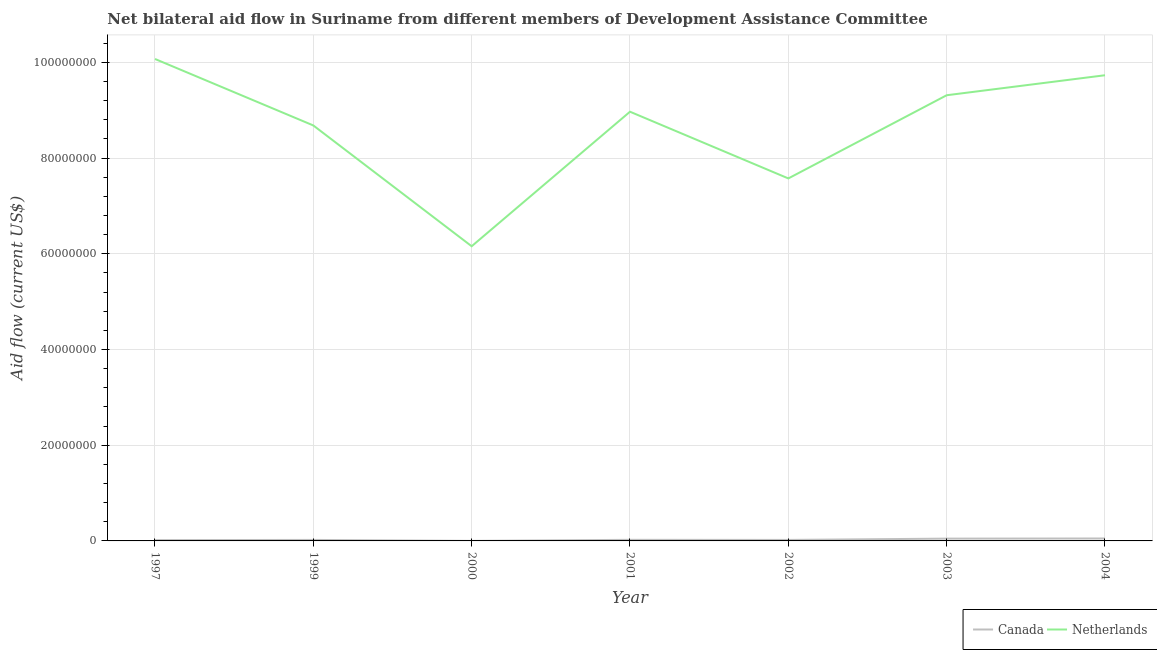Is the number of lines equal to the number of legend labels?
Your answer should be very brief. Yes. What is the amount of aid given by netherlands in 2004?
Provide a succinct answer. 9.73e+07. Across all years, what is the maximum amount of aid given by netherlands?
Provide a succinct answer. 1.01e+08. Across all years, what is the minimum amount of aid given by netherlands?
Your answer should be compact. 6.16e+07. What is the total amount of aid given by netherlands in the graph?
Ensure brevity in your answer.  6.05e+08. What is the difference between the amount of aid given by netherlands in 2001 and that in 2003?
Provide a short and direct response. -3.44e+06. What is the difference between the amount of aid given by netherlands in 2003 and the amount of aid given by canada in 1997?
Offer a very short reply. 9.30e+07. What is the average amount of aid given by netherlands per year?
Ensure brevity in your answer.  8.64e+07. In the year 1997, what is the difference between the amount of aid given by netherlands and amount of aid given by canada?
Offer a terse response. 1.01e+08. What is the ratio of the amount of aid given by netherlands in 2000 to that in 2001?
Your response must be concise. 0.69. Is the amount of aid given by netherlands in 1997 less than that in 2001?
Ensure brevity in your answer.  No. What is the difference between the highest and the second highest amount of aid given by netherlands?
Provide a short and direct response. 3.40e+06. What is the difference between the highest and the lowest amount of aid given by canada?
Your answer should be very brief. 5.00e+05. Is the sum of the amount of aid given by netherlands in 2002 and 2003 greater than the maximum amount of aid given by canada across all years?
Provide a short and direct response. Yes. Is the amount of aid given by netherlands strictly less than the amount of aid given by canada over the years?
Make the answer very short. No. What is the difference between two consecutive major ticks on the Y-axis?
Provide a short and direct response. 2.00e+07. Does the graph contain any zero values?
Offer a very short reply. No. Does the graph contain grids?
Provide a short and direct response. Yes. Where does the legend appear in the graph?
Your answer should be compact. Bottom right. How many legend labels are there?
Your response must be concise. 2. How are the legend labels stacked?
Keep it short and to the point. Horizontal. What is the title of the graph?
Provide a succinct answer. Net bilateral aid flow in Suriname from different members of Development Assistance Committee. Does "Domestic liabilities" appear as one of the legend labels in the graph?
Give a very brief answer. No. What is the label or title of the Y-axis?
Provide a short and direct response. Aid flow (current US$). What is the Aid flow (current US$) of Canada in 1997?
Offer a very short reply. 1.70e+05. What is the Aid flow (current US$) of Netherlands in 1997?
Make the answer very short. 1.01e+08. What is the Aid flow (current US$) of Netherlands in 1999?
Offer a very short reply. 8.68e+07. What is the Aid flow (current US$) of Netherlands in 2000?
Provide a succinct answer. 6.16e+07. What is the Aid flow (current US$) in Netherlands in 2001?
Keep it short and to the point. 8.97e+07. What is the Aid flow (current US$) in Canada in 2002?
Offer a terse response. 2.10e+05. What is the Aid flow (current US$) in Netherlands in 2002?
Your response must be concise. 7.57e+07. What is the Aid flow (current US$) in Canada in 2003?
Offer a very short reply. 4.80e+05. What is the Aid flow (current US$) in Netherlands in 2003?
Ensure brevity in your answer.  9.31e+07. What is the Aid flow (current US$) in Canada in 2004?
Keep it short and to the point. 5.10e+05. What is the Aid flow (current US$) in Netherlands in 2004?
Make the answer very short. 9.73e+07. Across all years, what is the maximum Aid flow (current US$) in Canada?
Make the answer very short. 5.10e+05. Across all years, what is the maximum Aid flow (current US$) of Netherlands?
Offer a terse response. 1.01e+08. Across all years, what is the minimum Aid flow (current US$) of Netherlands?
Make the answer very short. 6.16e+07. What is the total Aid flow (current US$) of Canada in the graph?
Keep it short and to the point. 1.82e+06. What is the total Aid flow (current US$) of Netherlands in the graph?
Keep it short and to the point. 6.05e+08. What is the difference between the Aid flow (current US$) of Canada in 1997 and that in 1999?
Your answer should be very brief. -4.00e+04. What is the difference between the Aid flow (current US$) of Netherlands in 1997 and that in 1999?
Offer a very short reply. 1.39e+07. What is the difference between the Aid flow (current US$) of Netherlands in 1997 and that in 2000?
Your answer should be very brief. 3.91e+07. What is the difference between the Aid flow (current US$) of Netherlands in 1997 and that in 2001?
Offer a terse response. 1.10e+07. What is the difference between the Aid flow (current US$) in Canada in 1997 and that in 2002?
Make the answer very short. -4.00e+04. What is the difference between the Aid flow (current US$) of Netherlands in 1997 and that in 2002?
Make the answer very short. 2.50e+07. What is the difference between the Aid flow (current US$) in Canada in 1997 and that in 2003?
Give a very brief answer. -3.10e+05. What is the difference between the Aid flow (current US$) in Netherlands in 1997 and that in 2003?
Keep it short and to the point. 7.58e+06. What is the difference between the Aid flow (current US$) of Canada in 1997 and that in 2004?
Give a very brief answer. -3.40e+05. What is the difference between the Aid flow (current US$) of Netherlands in 1997 and that in 2004?
Your answer should be compact. 3.40e+06. What is the difference between the Aid flow (current US$) of Netherlands in 1999 and that in 2000?
Your response must be concise. 2.52e+07. What is the difference between the Aid flow (current US$) of Canada in 1999 and that in 2001?
Ensure brevity in your answer.  -2.00e+04. What is the difference between the Aid flow (current US$) in Netherlands in 1999 and that in 2001?
Keep it short and to the point. -2.87e+06. What is the difference between the Aid flow (current US$) of Canada in 1999 and that in 2002?
Make the answer very short. 0. What is the difference between the Aid flow (current US$) of Netherlands in 1999 and that in 2002?
Provide a short and direct response. 1.11e+07. What is the difference between the Aid flow (current US$) in Canada in 1999 and that in 2003?
Offer a terse response. -2.70e+05. What is the difference between the Aid flow (current US$) in Netherlands in 1999 and that in 2003?
Offer a terse response. -6.31e+06. What is the difference between the Aid flow (current US$) of Canada in 1999 and that in 2004?
Your answer should be compact. -3.00e+05. What is the difference between the Aid flow (current US$) in Netherlands in 1999 and that in 2004?
Your response must be concise. -1.05e+07. What is the difference between the Aid flow (current US$) in Netherlands in 2000 and that in 2001?
Ensure brevity in your answer.  -2.81e+07. What is the difference between the Aid flow (current US$) of Netherlands in 2000 and that in 2002?
Your answer should be compact. -1.42e+07. What is the difference between the Aid flow (current US$) in Canada in 2000 and that in 2003?
Make the answer very short. -4.70e+05. What is the difference between the Aid flow (current US$) of Netherlands in 2000 and that in 2003?
Provide a short and direct response. -3.16e+07. What is the difference between the Aid flow (current US$) of Canada in 2000 and that in 2004?
Ensure brevity in your answer.  -5.00e+05. What is the difference between the Aid flow (current US$) in Netherlands in 2000 and that in 2004?
Your answer should be compact. -3.57e+07. What is the difference between the Aid flow (current US$) in Canada in 2001 and that in 2002?
Ensure brevity in your answer.  2.00e+04. What is the difference between the Aid flow (current US$) in Netherlands in 2001 and that in 2002?
Provide a succinct answer. 1.39e+07. What is the difference between the Aid flow (current US$) of Canada in 2001 and that in 2003?
Give a very brief answer. -2.50e+05. What is the difference between the Aid flow (current US$) of Netherlands in 2001 and that in 2003?
Offer a terse response. -3.44e+06. What is the difference between the Aid flow (current US$) in Canada in 2001 and that in 2004?
Your answer should be very brief. -2.80e+05. What is the difference between the Aid flow (current US$) of Netherlands in 2001 and that in 2004?
Make the answer very short. -7.62e+06. What is the difference between the Aid flow (current US$) of Canada in 2002 and that in 2003?
Your answer should be very brief. -2.70e+05. What is the difference between the Aid flow (current US$) of Netherlands in 2002 and that in 2003?
Ensure brevity in your answer.  -1.74e+07. What is the difference between the Aid flow (current US$) of Netherlands in 2002 and that in 2004?
Give a very brief answer. -2.16e+07. What is the difference between the Aid flow (current US$) of Canada in 2003 and that in 2004?
Keep it short and to the point. -3.00e+04. What is the difference between the Aid flow (current US$) in Netherlands in 2003 and that in 2004?
Give a very brief answer. -4.18e+06. What is the difference between the Aid flow (current US$) of Canada in 1997 and the Aid flow (current US$) of Netherlands in 1999?
Give a very brief answer. -8.66e+07. What is the difference between the Aid flow (current US$) in Canada in 1997 and the Aid flow (current US$) in Netherlands in 2000?
Give a very brief answer. -6.14e+07. What is the difference between the Aid flow (current US$) of Canada in 1997 and the Aid flow (current US$) of Netherlands in 2001?
Your answer should be compact. -8.95e+07. What is the difference between the Aid flow (current US$) in Canada in 1997 and the Aid flow (current US$) in Netherlands in 2002?
Give a very brief answer. -7.56e+07. What is the difference between the Aid flow (current US$) of Canada in 1997 and the Aid flow (current US$) of Netherlands in 2003?
Your response must be concise. -9.30e+07. What is the difference between the Aid flow (current US$) of Canada in 1997 and the Aid flow (current US$) of Netherlands in 2004?
Make the answer very short. -9.71e+07. What is the difference between the Aid flow (current US$) of Canada in 1999 and the Aid flow (current US$) of Netherlands in 2000?
Make the answer very short. -6.14e+07. What is the difference between the Aid flow (current US$) of Canada in 1999 and the Aid flow (current US$) of Netherlands in 2001?
Make the answer very short. -8.95e+07. What is the difference between the Aid flow (current US$) of Canada in 1999 and the Aid flow (current US$) of Netherlands in 2002?
Keep it short and to the point. -7.55e+07. What is the difference between the Aid flow (current US$) of Canada in 1999 and the Aid flow (current US$) of Netherlands in 2003?
Offer a very short reply. -9.29e+07. What is the difference between the Aid flow (current US$) of Canada in 1999 and the Aid flow (current US$) of Netherlands in 2004?
Offer a very short reply. -9.71e+07. What is the difference between the Aid flow (current US$) of Canada in 2000 and the Aid flow (current US$) of Netherlands in 2001?
Give a very brief answer. -8.97e+07. What is the difference between the Aid flow (current US$) of Canada in 2000 and the Aid flow (current US$) of Netherlands in 2002?
Your response must be concise. -7.57e+07. What is the difference between the Aid flow (current US$) of Canada in 2000 and the Aid flow (current US$) of Netherlands in 2003?
Provide a succinct answer. -9.31e+07. What is the difference between the Aid flow (current US$) in Canada in 2000 and the Aid flow (current US$) in Netherlands in 2004?
Your answer should be very brief. -9.73e+07. What is the difference between the Aid flow (current US$) of Canada in 2001 and the Aid flow (current US$) of Netherlands in 2002?
Provide a short and direct response. -7.55e+07. What is the difference between the Aid flow (current US$) in Canada in 2001 and the Aid flow (current US$) in Netherlands in 2003?
Provide a succinct answer. -9.29e+07. What is the difference between the Aid flow (current US$) in Canada in 2001 and the Aid flow (current US$) in Netherlands in 2004?
Give a very brief answer. -9.71e+07. What is the difference between the Aid flow (current US$) in Canada in 2002 and the Aid flow (current US$) in Netherlands in 2003?
Give a very brief answer. -9.29e+07. What is the difference between the Aid flow (current US$) in Canada in 2002 and the Aid flow (current US$) in Netherlands in 2004?
Offer a terse response. -9.71e+07. What is the difference between the Aid flow (current US$) of Canada in 2003 and the Aid flow (current US$) of Netherlands in 2004?
Offer a terse response. -9.68e+07. What is the average Aid flow (current US$) of Canada per year?
Offer a very short reply. 2.60e+05. What is the average Aid flow (current US$) of Netherlands per year?
Give a very brief answer. 8.64e+07. In the year 1997, what is the difference between the Aid flow (current US$) in Canada and Aid flow (current US$) in Netherlands?
Provide a short and direct response. -1.01e+08. In the year 1999, what is the difference between the Aid flow (current US$) in Canada and Aid flow (current US$) in Netherlands?
Provide a succinct answer. -8.66e+07. In the year 2000, what is the difference between the Aid flow (current US$) of Canada and Aid flow (current US$) of Netherlands?
Offer a terse response. -6.16e+07. In the year 2001, what is the difference between the Aid flow (current US$) of Canada and Aid flow (current US$) of Netherlands?
Your response must be concise. -8.94e+07. In the year 2002, what is the difference between the Aid flow (current US$) in Canada and Aid flow (current US$) in Netherlands?
Provide a succinct answer. -7.55e+07. In the year 2003, what is the difference between the Aid flow (current US$) in Canada and Aid flow (current US$) in Netherlands?
Provide a succinct answer. -9.26e+07. In the year 2004, what is the difference between the Aid flow (current US$) of Canada and Aid flow (current US$) of Netherlands?
Your answer should be compact. -9.68e+07. What is the ratio of the Aid flow (current US$) of Canada in 1997 to that in 1999?
Give a very brief answer. 0.81. What is the ratio of the Aid flow (current US$) of Netherlands in 1997 to that in 1999?
Provide a succinct answer. 1.16. What is the ratio of the Aid flow (current US$) in Canada in 1997 to that in 2000?
Your response must be concise. 17. What is the ratio of the Aid flow (current US$) in Netherlands in 1997 to that in 2000?
Ensure brevity in your answer.  1.64. What is the ratio of the Aid flow (current US$) in Canada in 1997 to that in 2001?
Offer a terse response. 0.74. What is the ratio of the Aid flow (current US$) of Netherlands in 1997 to that in 2001?
Your response must be concise. 1.12. What is the ratio of the Aid flow (current US$) in Canada in 1997 to that in 2002?
Give a very brief answer. 0.81. What is the ratio of the Aid flow (current US$) in Netherlands in 1997 to that in 2002?
Provide a succinct answer. 1.33. What is the ratio of the Aid flow (current US$) in Canada in 1997 to that in 2003?
Provide a short and direct response. 0.35. What is the ratio of the Aid flow (current US$) in Netherlands in 1997 to that in 2003?
Your response must be concise. 1.08. What is the ratio of the Aid flow (current US$) of Canada in 1997 to that in 2004?
Provide a short and direct response. 0.33. What is the ratio of the Aid flow (current US$) in Netherlands in 1997 to that in 2004?
Provide a short and direct response. 1.03. What is the ratio of the Aid flow (current US$) of Canada in 1999 to that in 2000?
Offer a terse response. 21. What is the ratio of the Aid flow (current US$) in Netherlands in 1999 to that in 2000?
Offer a terse response. 1.41. What is the ratio of the Aid flow (current US$) in Canada in 1999 to that in 2001?
Provide a short and direct response. 0.91. What is the ratio of the Aid flow (current US$) of Netherlands in 1999 to that in 2001?
Offer a terse response. 0.97. What is the ratio of the Aid flow (current US$) in Netherlands in 1999 to that in 2002?
Provide a succinct answer. 1.15. What is the ratio of the Aid flow (current US$) of Canada in 1999 to that in 2003?
Your response must be concise. 0.44. What is the ratio of the Aid flow (current US$) in Netherlands in 1999 to that in 2003?
Make the answer very short. 0.93. What is the ratio of the Aid flow (current US$) in Canada in 1999 to that in 2004?
Ensure brevity in your answer.  0.41. What is the ratio of the Aid flow (current US$) of Netherlands in 1999 to that in 2004?
Your response must be concise. 0.89. What is the ratio of the Aid flow (current US$) in Canada in 2000 to that in 2001?
Your response must be concise. 0.04. What is the ratio of the Aid flow (current US$) of Netherlands in 2000 to that in 2001?
Provide a short and direct response. 0.69. What is the ratio of the Aid flow (current US$) of Canada in 2000 to that in 2002?
Give a very brief answer. 0.05. What is the ratio of the Aid flow (current US$) in Netherlands in 2000 to that in 2002?
Ensure brevity in your answer.  0.81. What is the ratio of the Aid flow (current US$) in Canada in 2000 to that in 2003?
Your answer should be compact. 0.02. What is the ratio of the Aid flow (current US$) of Netherlands in 2000 to that in 2003?
Ensure brevity in your answer.  0.66. What is the ratio of the Aid flow (current US$) of Canada in 2000 to that in 2004?
Your answer should be compact. 0.02. What is the ratio of the Aid flow (current US$) in Netherlands in 2000 to that in 2004?
Offer a terse response. 0.63. What is the ratio of the Aid flow (current US$) in Canada in 2001 to that in 2002?
Make the answer very short. 1.1. What is the ratio of the Aid flow (current US$) of Netherlands in 2001 to that in 2002?
Keep it short and to the point. 1.18. What is the ratio of the Aid flow (current US$) of Canada in 2001 to that in 2003?
Your answer should be very brief. 0.48. What is the ratio of the Aid flow (current US$) in Netherlands in 2001 to that in 2003?
Your answer should be very brief. 0.96. What is the ratio of the Aid flow (current US$) in Canada in 2001 to that in 2004?
Your answer should be very brief. 0.45. What is the ratio of the Aid flow (current US$) in Netherlands in 2001 to that in 2004?
Your answer should be compact. 0.92. What is the ratio of the Aid flow (current US$) of Canada in 2002 to that in 2003?
Provide a succinct answer. 0.44. What is the ratio of the Aid flow (current US$) of Netherlands in 2002 to that in 2003?
Ensure brevity in your answer.  0.81. What is the ratio of the Aid flow (current US$) of Canada in 2002 to that in 2004?
Give a very brief answer. 0.41. What is the ratio of the Aid flow (current US$) in Netherlands in 2002 to that in 2004?
Offer a very short reply. 0.78. What is the difference between the highest and the second highest Aid flow (current US$) of Netherlands?
Provide a short and direct response. 3.40e+06. What is the difference between the highest and the lowest Aid flow (current US$) of Netherlands?
Your response must be concise. 3.91e+07. 